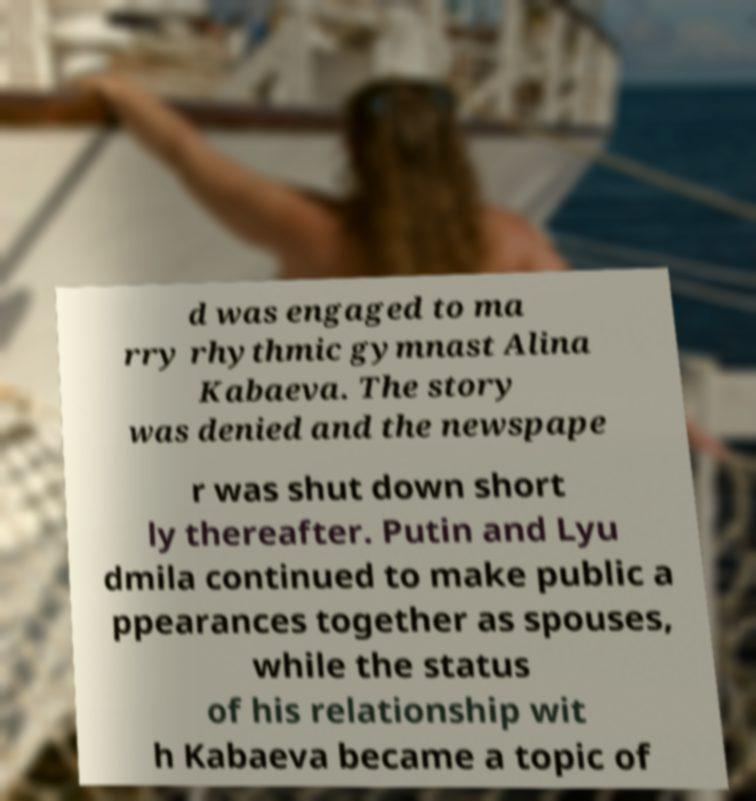Please read and relay the text visible in this image. What does it say? d was engaged to ma rry rhythmic gymnast Alina Kabaeva. The story was denied and the newspape r was shut down short ly thereafter. Putin and Lyu dmila continued to make public a ppearances together as spouses, while the status of his relationship wit h Kabaeva became a topic of 